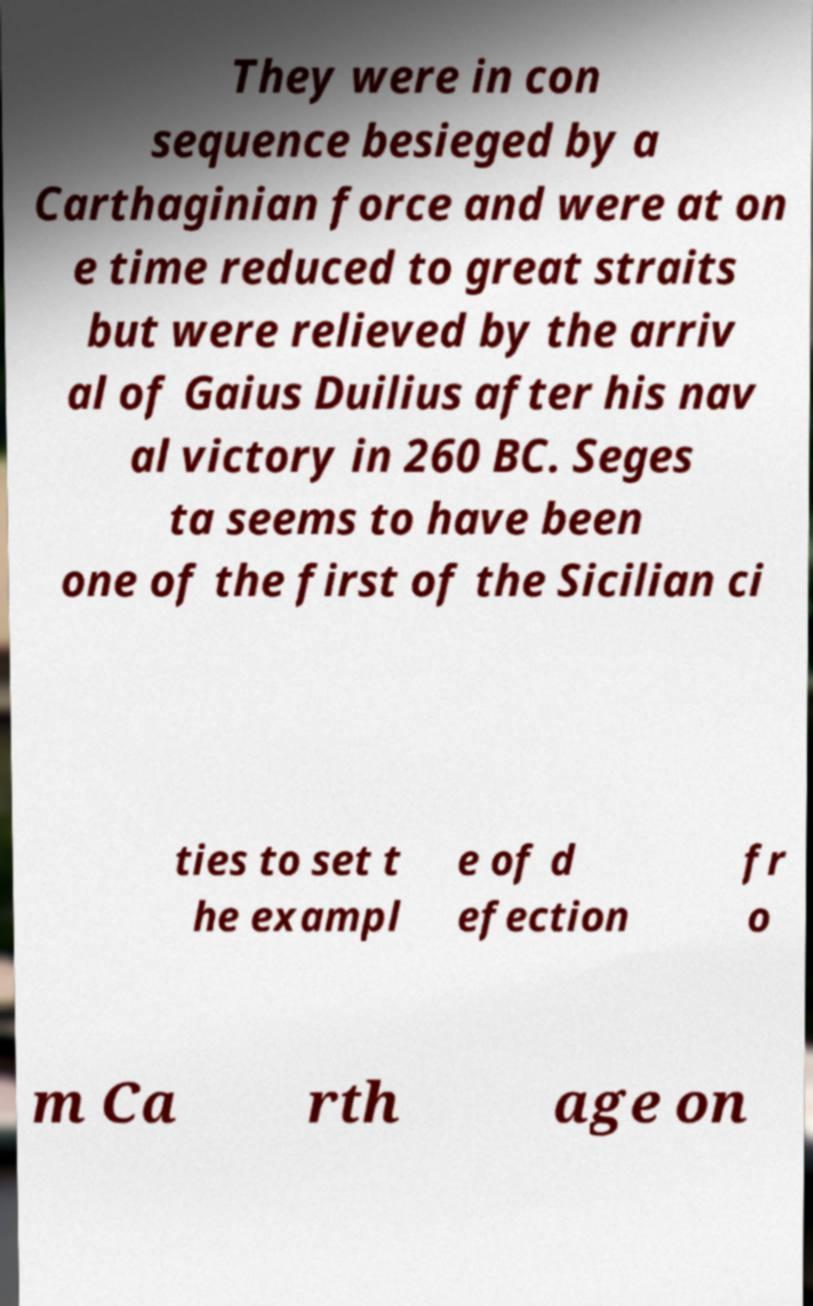Please identify and transcribe the text found in this image. They were in con sequence besieged by a Carthaginian force and were at on e time reduced to great straits but were relieved by the arriv al of Gaius Duilius after his nav al victory in 260 BC. Seges ta seems to have been one of the first of the Sicilian ci ties to set t he exampl e of d efection fr o m Ca rth age on 